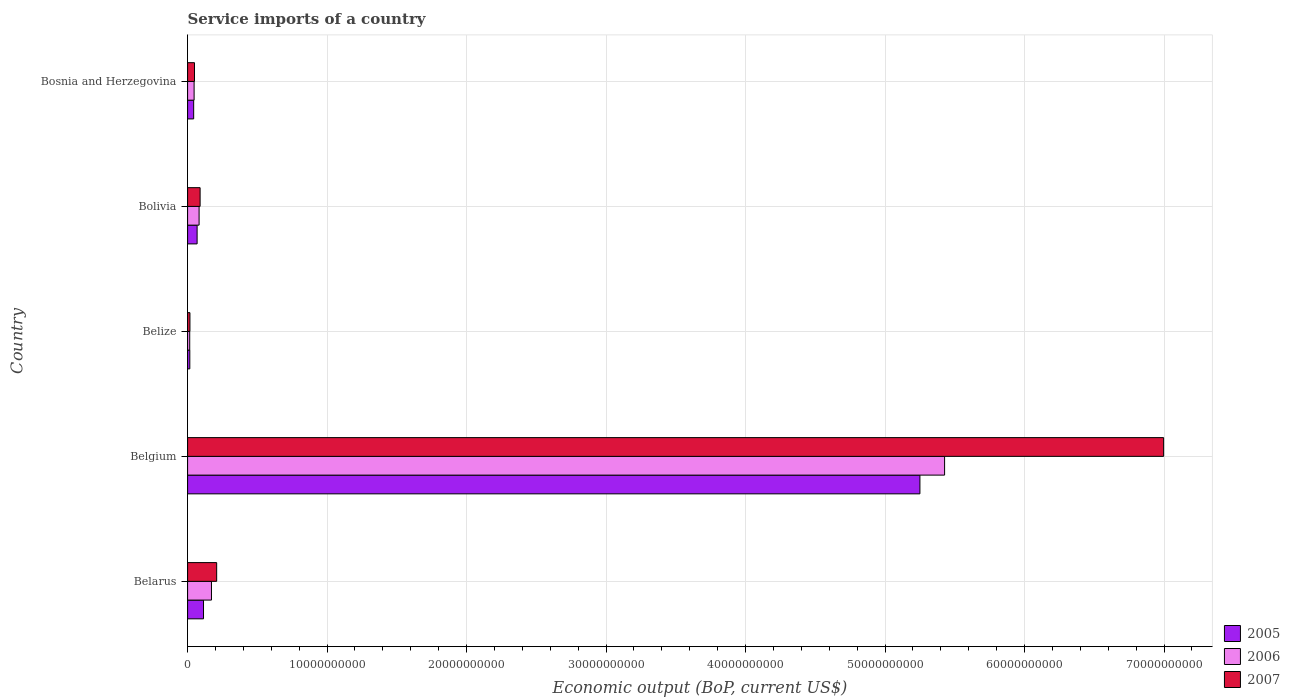How many different coloured bars are there?
Offer a terse response. 3. How many bars are there on the 2nd tick from the bottom?
Keep it short and to the point. 3. What is the label of the 5th group of bars from the top?
Keep it short and to the point. Belarus. What is the service imports in 2007 in Bosnia and Herzegovina?
Your response must be concise. 4.95e+08. Across all countries, what is the maximum service imports in 2006?
Keep it short and to the point. 5.43e+1. Across all countries, what is the minimum service imports in 2007?
Offer a terse response. 1.68e+08. In which country was the service imports in 2006 minimum?
Give a very brief answer. Belize. What is the total service imports in 2005 in the graph?
Provide a succinct answer. 5.49e+1. What is the difference between the service imports in 2006 in Belgium and that in Bolivia?
Your answer should be very brief. 5.34e+1. What is the difference between the service imports in 2005 in Bolivia and the service imports in 2006 in Belarus?
Offer a very short reply. -1.03e+09. What is the average service imports in 2007 per country?
Your answer should be compact. 1.47e+1. What is the difference between the service imports in 2005 and service imports in 2007 in Belgium?
Ensure brevity in your answer.  -1.75e+1. In how many countries, is the service imports in 2006 greater than 26000000000 US$?
Ensure brevity in your answer.  1. What is the ratio of the service imports in 2007 in Belarus to that in Bosnia and Herzegovina?
Provide a short and direct response. 4.21. What is the difference between the highest and the second highest service imports in 2005?
Give a very brief answer. 5.14e+1. What is the difference between the highest and the lowest service imports in 2006?
Ensure brevity in your answer.  5.41e+1. In how many countries, is the service imports in 2005 greater than the average service imports in 2005 taken over all countries?
Offer a very short reply. 1. Is the sum of the service imports in 2006 in Belarus and Bolivia greater than the maximum service imports in 2005 across all countries?
Ensure brevity in your answer.  No. What does the 1st bar from the top in Belarus represents?
Make the answer very short. 2007. How many bars are there?
Your answer should be compact. 15. Are all the bars in the graph horizontal?
Offer a terse response. Yes. How many countries are there in the graph?
Ensure brevity in your answer.  5. What is the title of the graph?
Provide a short and direct response. Service imports of a country. What is the label or title of the X-axis?
Give a very brief answer. Economic output (BoP, current US$). What is the label or title of the Y-axis?
Provide a short and direct response. Country. What is the Economic output (BoP, current US$) in 2005 in Belarus?
Provide a short and direct response. 1.14e+09. What is the Economic output (BoP, current US$) in 2006 in Belarus?
Keep it short and to the point. 1.71e+09. What is the Economic output (BoP, current US$) of 2007 in Belarus?
Give a very brief answer. 2.08e+09. What is the Economic output (BoP, current US$) of 2005 in Belgium?
Your response must be concise. 5.25e+1. What is the Economic output (BoP, current US$) of 2006 in Belgium?
Provide a succinct answer. 5.43e+1. What is the Economic output (BoP, current US$) of 2007 in Belgium?
Provide a succinct answer. 7.00e+1. What is the Economic output (BoP, current US$) of 2005 in Belize?
Offer a terse response. 1.59e+08. What is the Economic output (BoP, current US$) of 2006 in Belize?
Your answer should be very brief. 1.52e+08. What is the Economic output (BoP, current US$) of 2007 in Belize?
Provide a succinct answer. 1.68e+08. What is the Economic output (BoP, current US$) in 2005 in Bolivia?
Your answer should be very brief. 6.82e+08. What is the Economic output (BoP, current US$) of 2006 in Bolivia?
Give a very brief answer. 8.25e+08. What is the Economic output (BoP, current US$) of 2007 in Bolivia?
Make the answer very short. 8.97e+08. What is the Economic output (BoP, current US$) of 2005 in Bosnia and Herzegovina?
Your answer should be compact. 4.36e+08. What is the Economic output (BoP, current US$) in 2006 in Bosnia and Herzegovina?
Your answer should be very brief. 4.67e+08. What is the Economic output (BoP, current US$) of 2007 in Bosnia and Herzegovina?
Provide a succinct answer. 4.95e+08. Across all countries, what is the maximum Economic output (BoP, current US$) of 2005?
Your response must be concise. 5.25e+1. Across all countries, what is the maximum Economic output (BoP, current US$) of 2006?
Keep it short and to the point. 5.43e+1. Across all countries, what is the maximum Economic output (BoP, current US$) of 2007?
Offer a terse response. 7.00e+1. Across all countries, what is the minimum Economic output (BoP, current US$) of 2005?
Your response must be concise. 1.59e+08. Across all countries, what is the minimum Economic output (BoP, current US$) of 2006?
Offer a very short reply. 1.52e+08. Across all countries, what is the minimum Economic output (BoP, current US$) of 2007?
Provide a short and direct response. 1.68e+08. What is the total Economic output (BoP, current US$) of 2005 in the graph?
Provide a short and direct response. 5.49e+1. What is the total Economic output (BoP, current US$) in 2006 in the graph?
Make the answer very short. 5.74e+1. What is the total Economic output (BoP, current US$) in 2007 in the graph?
Provide a short and direct response. 7.36e+1. What is the difference between the Economic output (BoP, current US$) in 2005 in Belarus and that in Belgium?
Offer a very short reply. -5.14e+1. What is the difference between the Economic output (BoP, current US$) in 2006 in Belarus and that in Belgium?
Your response must be concise. -5.26e+1. What is the difference between the Economic output (BoP, current US$) in 2007 in Belarus and that in Belgium?
Make the answer very short. -6.79e+1. What is the difference between the Economic output (BoP, current US$) of 2005 in Belarus and that in Belize?
Your answer should be very brief. 9.82e+08. What is the difference between the Economic output (BoP, current US$) of 2006 in Belarus and that in Belize?
Make the answer very short. 1.56e+09. What is the difference between the Economic output (BoP, current US$) in 2007 in Belarus and that in Belize?
Your response must be concise. 1.92e+09. What is the difference between the Economic output (BoP, current US$) in 2005 in Belarus and that in Bolivia?
Your response must be concise. 4.59e+08. What is the difference between the Economic output (BoP, current US$) in 2006 in Belarus and that in Bolivia?
Your answer should be very brief. 8.86e+08. What is the difference between the Economic output (BoP, current US$) in 2007 in Belarus and that in Bolivia?
Offer a very short reply. 1.19e+09. What is the difference between the Economic output (BoP, current US$) in 2005 in Belarus and that in Bosnia and Herzegovina?
Ensure brevity in your answer.  7.05e+08. What is the difference between the Economic output (BoP, current US$) of 2006 in Belarus and that in Bosnia and Herzegovina?
Offer a terse response. 1.24e+09. What is the difference between the Economic output (BoP, current US$) in 2007 in Belarus and that in Bosnia and Herzegovina?
Your answer should be compact. 1.59e+09. What is the difference between the Economic output (BoP, current US$) of 2005 in Belgium and that in Belize?
Your answer should be compact. 5.23e+1. What is the difference between the Economic output (BoP, current US$) in 2006 in Belgium and that in Belize?
Give a very brief answer. 5.41e+1. What is the difference between the Economic output (BoP, current US$) of 2007 in Belgium and that in Belize?
Your response must be concise. 6.98e+1. What is the difference between the Economic output (BoP, current US$) in 2005 in Belgium and that in Bolivia?
Provide a short and direct response. 5.18e+1. What is the difference between the Economic output (BoP, current US$) of 2006 in Belgium and that in Bolivia?
Make the answer very short. 5.34e+1. What is the difference between the Economic output (BoP, current US$) of 2007 in Belgium and that in Bolivia?
Keep it short and to the point. 6.91e+1. What is the difference between the Economic output (BoP, current US$) in 2005 in Belgium and that in Bosnia and Herzegovina?
Provide a succinct answer. 5.21e+1. What is the difference between the Economic output (BoP, current US$) in 2006 in Belgium and that in Bosnia and Herzegovina?
Keep it short and to the point. 5.38e+1. What is the difference between the Economic output (BoP, current US$) of 2007 in Belgium and that in Bosnia and Herzegovina?
Offer a very short reply. 6.95e+1. What is the difference between the Economic output (BoP, current US$) of 2005 in Belize and that in Bolivia?
Give a very brief answer. -5.23e+08. What is the difference between the Economic output (BoP, current US$) in 2006 in Belize and that in Bolivia?
Provide a short and direct response. -6.73e+08. What is the difference between the Economic output (BoP, current US$) in 2007 in Belize and that in Bolivia?
Make the answer very short. -7.29e+08. What is the difference between the Economic output (BoP, current US$) of 2005 in Belize and that in Bosnia and Herzegovina?
Offer a very short reply. -2.77e+08. What is the difference between the Economic output (BoP, current US$) of 2006 in Belize and that in Bosnia and Herzegovina?
Offer a terse response. -3.15e+08. What is the difference between the Economic output (BoP, current US$) of 2007 in Belize and that in Bosnia and Herzegovina?
Your response must be concise. -3.27e+08. What is the difference between the Economic output (BoP, current US$) of 2005 in Bolivia and that in Bosnia and Herzegovina?
Your answer should be compact. 2.46e+08. What is the difference between the Economic output (BoP, current US$) in 2006 in Bolivia and that in Bosnia and Herzegovina?
Provide a short and direct response. 3.58e+08. What is the difference between the Economic output (BoP, current US$) in 2007 in Bolivia and that in Bosnia and Herzegovina?
Give a very brief answer. 4.01e+08. What is the difference between the Economic output (BoP, current US$) in 2005 in Belarus and the Economic output (BoP, current US$) in 2006 in Belgium?
Keep it short and to the point. -5.31e+1. What is the difference between the Economic output (BoP, current US$) of 2005 in Belarus and the Economic output (BoP, current US$) of 2007 in Belgium?
Give a very brief answer. -6.88e+1. What is the difference between the Economic output (BoP, current US$) of 2006 in Belarus and the Economic output (BoP, current US$) of 2007 in Belgium?
Provide a short and direct response. -6.83e+1. What is the difference between the Economic output (BoP, current US$) of 2005 in Belarus and the Economic output (BoP, current US$) of 2006 in Belize?
Make the answer very short. 9.89e+08. What is the difference between the Economic output (BoP, current US$) of 2005 in Belarus and the Economic output (BoP, current US$) of 2007 in Belize?
Keep it short and to the point. 9.73e+08. What is the difference between the Economic output (BoP, current US$) in 2006 in Belarus and the Economic output (BoP, current US$) in 2007 in Belize?
Your answer should be very brief. 1.54e+09. What is the difference between the Economic output (BoP, current US$) of 2005 in Belarus and the Economic output (BoP, current US$) of 2006 in Bolivia?
Make the answer very short. 3.16e+08. What is the difference between the Economic output (BoP, current US$) in 2005 in Belarus and the Economic output (BoP, current US$) in 2007 in Bolivia?
Give a very brief answer. 2.44e+08. What is the difference between the Economic output (BoP, current US$) of 2006 in Belarus and the Economic output (BoP, current US$) of 2007 in Bolivia?
Offer a very short reply. 8.14e+08. What is the difference between the Economic output (BoP, current US$) in 2005 in Belarus and the Economic output (BoP, current US$) in 2006 in Bosnia and Herzegovina?
Your answer should be compact. 6.74e+08. What is the difference between the Economic output (BoP, current US$) in 2005 in Belarus and the Economic output (BoP, current US$) in 2007 in Bosnia and Herzegovina?
Your response must be concise. 6.46e+08. What is the difference between the Economic output (BoP, current US$) of 2006 in Belarus and the Economic output (BoP, current US$) of 2007 in Bosnia and Herzegovina?
Your answer should be very brief. 1.22e+09. What is the difference between the Economic output (BoP, current US$) in 2005 in Belgium and the Economic output (BoP, current US$) in 2006 in Belize?
Your response must be concise. 5.23e+1. What is the difference between the Economic output (BoP, current US$) of 2005 in Belgium and the Economic output (BoP, current US$) of 2007 in Belize?
Provide a succinct answer. 5.23e+1. What is the difference between the Economic output (BoP, current US$) of 2006 in Belgium and the Economic output (BoP, current US$) of 2007 in Belize?
Offer a terse response. 5.41e+1. What is the difference between the Economic output (BoP, current US$) in 2005 in Belgium and the Economic output (BoP, current US$) in 2006 in Bolivia?
Make the answer very short. 5.17e+1. What is the difference between the Economic output (BoP, current US$) of 2005 in Belgium and the Economic output (BoP, current US$) of 2007 in Bolivia?
Provide a succinct answer. 5.16e+1. What is the difference between the Economic output (BoP, current US$) in 2006 in Belgium and the Economic output (BoP, current US$) in 2007 in Bolivia?
Your response must be concise. 5.34e+1. What is the difference between the Economic output (BoP, current US$) in 2005 in Belgium and the Economic output (BoP, current US$) in 2006 in Bosnia and Herzegovina?
Give a very brief answer. 5.20e+1. What is the difference between the Economic output (BoP, current US$) in 2005 in Belgium and the Economic output (BoP, current US$) in 2007 in Bosnia and Herzegovina?
Ensure brevity in your answer.  5.20e+1. What is the difference between the Economic output (BoP, current US$) of 2006 in Belgium and the Economic output (BoP, current US$) of 2007 in Bosnia and Herzegovina?
Your answer should be very brief. 5.38e+1. What is the difference between the Economic output (BoP, current US$) in 2005 in Belize and the Economic output (BoP, current US$) in 2006 in Bolivia?
Keep it short and to the point. -6.66e+08. What is the difference between the Economic output (BoP, current US$) in 2005 in Belize and the Economic output (BoP, current US$) in 2007 in Bolivia?
Offer a terse response. -7.38e+08. What is the difference between the Economic output (BoP, current US$) of 2006 in Belize and the Economic output (BoP, current US$) of 2007 in Bolivia?
Offer a very short reply. -7.45e+08. What is the difference between the Economic output (BoP, current US$) of 2005 in Belize and the Economic output (BoP, current US$) of 2006 in Bosnia and Herzegovina?
Your response must be concise. -3.08e+08. What is the difference between the Economic output (BoP, current US$) of 2005 in Belize and the Economic output (BoP, current US$) of 2007 in Bosnia and Herzegovina?
Your response must be concise. -3.37e+08. What is the difference between the Economic output (BoP, current US$) of 2006 in Belize and the Economic output (BoP, current US$) of 2007 in Bosnia and Herzegovina?
Your answer should be very brief. -3.43e+08. What is the difference between the Economic output (BoP, current US$) of 2005 in Bolivia and the Economic output (BoP, current US$) of 2006 in Bosnia and Herzegovina?
Give a very brief answer. 2.15e+08. What is the difference between the Economic output (BoP, current US$) of 2005 in Bolivia and the Economic output (BoP, current US$) of 2007 in Bosnia and Herzegovina?
Keep it short and to the point. 1.87e+08. What is the difference between the Economic output (BoP, current US$) of 2006 in Bolivia and the Economic output (BoP, current US$) of 2007 in Bosnia and Herzegovina?
Your answer should be compact. 3.29e+08. What is the average Economic output (BoP, current US$) in 2005 per country?
Your answer should be very brief. 1.10e+1. What is the average Economic output (BoP, current US$) of 2006 per country?
Your response must be concise. 1.15e+1. What is the average Economic output (BoP, current US$) in 2007 per country?
Ensure brevity in your answer.  1.47e+1. What is the difference between the Economic output (BoP, current US$) in 2005 and Economic output (BoP, current US$) in 2006 in Belarus?
Ensure brevity in your answer.  -5.70e+08. What is the difference between the Economic output (BoP, current US$) of 2005 and Economic output (BoP, current US$) of 2007 in Belarus?
Offer a very short reply. -9.44e+08. What is the difference between the Economic output (BoP, current US$) in 2006 and Economic output (BoP, current US$) in 2007 in Belarus?
Provide a short and direct response. -3.74e+08. What is the difference between the Economic output (BoP, current US$) of 2005 and Economic output (BoP, current US$) of 2006 in Belgium?
Provide a short and direct response. -1.77e+09. What is the difference between the Economic output (BoP, current US$) in 2005 and Economic output (BoP, current US$) in 2007 in Belgium?
Provide a short and direct response. -1.75e+1. What is the difference between the Economic output (BoP, current US$) in 2006 and Economic output (BoP, current US$) in 2007 in Belgium?
Make the answer very short. -1.57e+1. What is the difference between the Economic output (BoP, current US$) of 2005 and Economic output (BoP, current US$) of 2006 in Belize?
Provide a short and direct response. 6.63e+06. What is the difference between the Economic output (BoP, current US$) in 2005 and Economic output (BoP, current US$) in 2007 in Belize?
Your answer should be very brief. -9.36e+06. What is the difference between the Economic output (BoP, current US$) of 2006 and Economic output (BoP, current US$) of 2007 in Belize?
Your answer should be compact. -1.60e+07. What is the difference between the Economic output (BoP, current US$) in 2005 and Economic output (BoP, current US$) in 2006 in Bolivia?
Your answer should be compact. -1.43e+08. What is the difference between the Economic output (BoP, current US$) in 2005 and Economic output (BoP, current US$) in 2007 in Bolivia?
Provide a succinct answer. -2.15e+08. What is the difference between the Economic output (BoP, current US$) of 2006 and Economic output (BoP, current US$) of 2007 in Bolivia?
Keep it short and to the point. -7.19e+07. What is the difference between the Economic output (BoP, current US$) of 2005 and Economic output (BoP, current US$) of 2006 in Bosnia and Herzegovina?
Provide a succinct answer. -3.12e+07. What is the difference between the Economic output (BoP, current US$) in 2005 and Economic output (BoP, current US$) in 2007 in Bosnia and Herzegovina?
Your answer should be compact. -5.97e+07. What is the difference between the Economic output (BoP, current US$) in 2006 and Economic output (BoP, current US$) in 2007 in Bosnia and Herzegovina?
Provide a short and direct response. -2.86e+07. What is the ratio of the Economic output (BoP, current US$) in 2005 in Belarus to that in Belgium?
Make the answer very short. 0.02. What is the ratio of the Economic output (BoP, current US$) of 2006 in Belarus to that in Belgium?
Provide a succinct answer. 0.03. What is the ratio of the Economic output (BoP, current US$) of 2007 in Belarus to that in Belgium?
Offer a very short reply. 0.03. What is the ratio of the Economic output (BoP, current US$) in 2005 in Belarus to that in Belize?
Ensure brevity in your answer.  7.19. What is the ratio of the Economic output (BoP, current US$) of 2006 in Belarus to that in Belize?
Your response must be concise. 11.25. What is the ratio of the Economic output (BoP, current US$) of 2007 in Belarus to that in Belize?
Ensure brevity in your answer.  12.4. What is the ratio of the Economic output (BoP, current US$) of 2005 in Belarus to that in Bolivia?
Offer a terse response. 1.67. What is the ratio of the Economic output (BoP, current US$) of 2006 in Belarus to that in Bolivia?
Your answer should be compact. 2.07. What is the ratio of the Economic output (BoP, current US$) of 2007 in Belarus to that in Bolivia?
Provide a succinct answer. 2.32. What is the ratio of the Economic output (BoP, current US$) of 2005 in Belarus to that in Bosnia and Herzegovina?
Your response must be concise. 2.62. What is the ratio of the Economic output (BoP, current US$) in 2006 in Belarus to that in Bosnia and Herzegovina?
Ensure brevity in your answer.  3.67. What is the ratio of the Economic output (BoP, current US$) of 2007 in Belarus to that in Bosnia and Herzegovina?
Make the answer very short. 4.21. What is the ratio of the Economic output (BoP, current US$) of 2005 in Belgium to that in Belize?
Make the answer very short. 330.62. What is the ratio of the Economic output (BoP, current US$) in 2006 in Belgium to that in Belize?
Your answer should be very brief. 356.66. What is the ratio of the Economic output (BoP, current US$) of 2007 in Belgium to that in Belize?
Provide a succinct answer. 416.11. What is the ratio of the Economic output (BoP, current US$) in 2005 in Belgium to that in Bolivia?
Keep it short and to the point. 76.98. What is the ratio of the Economic output (BoP, current US$) in 2006 in Belgium to that in Bolivia?
Give a very brief answer. 65.8. What is the ratio of the Economic output (BoP, current US$) in 2007 in Belgium to that in Bolivia?
Offer a very short reply. 78.03. What is the ratio of the Economic output (BoP, current US$) of 2005 in Belgium to that in Bosnia and Herzegovina?
Ensure brevity in your answer.  120.53. What is the ratio of the Economic output (BoP, current US$) in 2006 in Belgium to that in Bosnia and Herzegovina?
Ensure brevity in your answer.  116.28. What is the ratio of the Economic output (BoP, current US$) of 2007 in Belgium to that in Bosnia and Herzegovina?
Make the answer very short. 141.27. What is the ratio of the Economic output (BoP, current US$) in 2005 in Belize to that in Bolivia?
Your answer should be compact. 0.23. What is the ratio of the Economic output (BoP, current US$) in 2006 in Belize to that in Bolivia?
Your answer should be compact. 0.18. What is the ratio of the Economic output (BoP, current US$) in 2007 in Belize to that in Bolivia?
Keep it short and to the point. 0.19. What is the ratio of the Economic output (BoP, current US$) of 2005 in Belize to that in Bosnia and Herzegovina?
Keep it short and to the point. 0.36. What is the ratio of the Economic output (BoP, current US$) in 2006 in Belize to that in Bosnia and Herzegovina?
Offer a terse response. 0.33. What is the ratio of the Economic output (BoP, current US$) in 2007 in Belize to that in Bosnia and Herzegovina?
Your response must be concise. 0.34. What is the ratio of the Economic output (BoP, current US$) in 2005 in Bolivia to that in Bosnia and Herzegovina?
Provide a short and direct response. 1.57. What is the ratio of the Economic output (BoP, current US$) of 2006 in Bolivia to that in Bosnia and Herzegovina?
Give a very brief answer. 1.77. What is the ratio of the Economic output (BoP, current US$) in 2007 in Bolivia to that in Bosnia and Herzegovina?
Keep it short and to the point. 1.81. What is the difference between the highest and the second highest Economic output (BoP, current US$) in 2005?
Your answer should be compact. 5.14e+1. What is the difference between the highest and the second highest Economic output (BoP, current US$) of 2006?
Provide a succinct answer. 5.26e+1. What is the difference between the highest and the second highest Economic output (BoP, current US$) of 2007?
Make the answer very short. 6.79e+1. What is the difference between the highest and the lowest Economic output (BoP, current US$) of 2005?
Your response must be concise. 5.23e+1. What is the difference between the highest and the lowest Economic output (BoP, current US$) of 2006?
Ensure brevity in your answer.  5.41e+1. What is the difference between the highest and the lowest Economic output (BoP, current US$) of 2007?
Your response must be concise. 6.98e+1. 